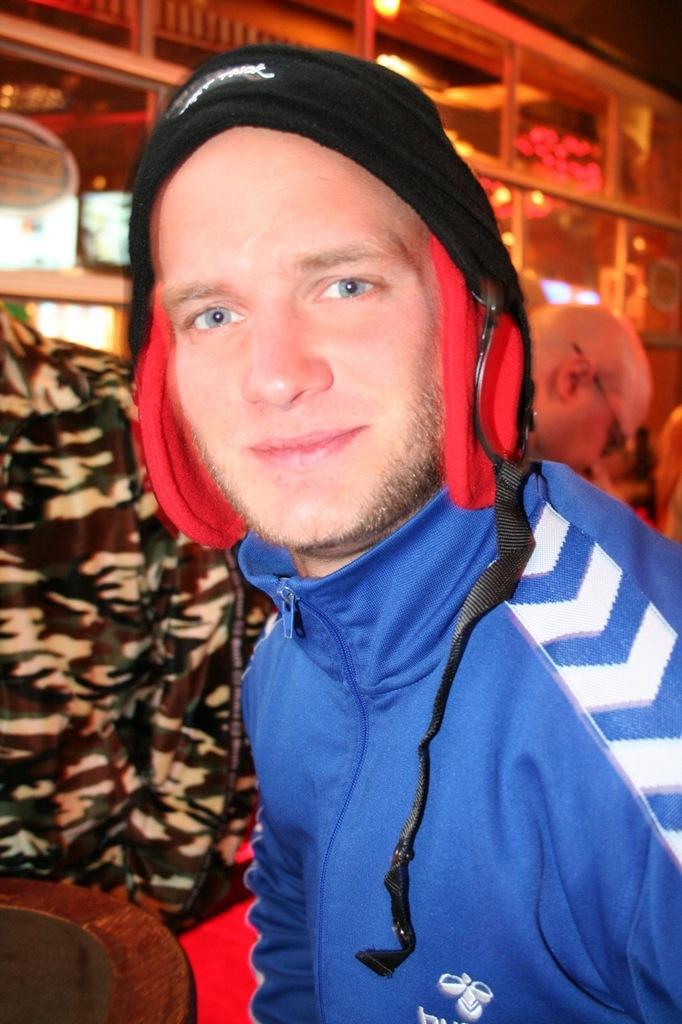Please provide a concise description of this image. In front of the image there is a person. Behind him there are a few other people. In the background of the image there is a poster on the glass door. On top of the image there is a light. 